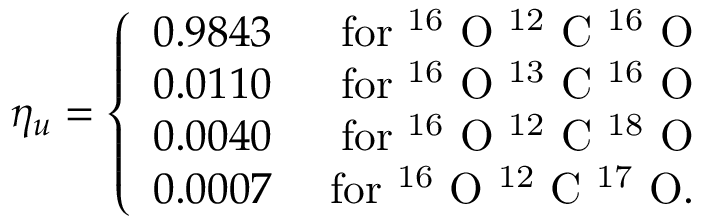<formula> <loc_0><loc_0><loc_500><loc_500>\eta _ { u } = \left \{ \begin{array} { r r } { 0 . 9 8 4 3 } & { f o r ^ { 1 6 } O ^ { 1 2 } C ^ { 1 6 } O } \\ { 0 . 0 1 1 0 } & { f o r ^ { 1 6 } O ^ { 1 3 } C ^ { 1 6 } O } \\ { 0 . 0 0 4 0 } & { f o r ^ { 1 6 } O ^ { 1 2 } C ^ { 1 8 } O } \\ { 0 . 0 0 0 7 } & { f o r ^ { 1 6 } O ^ { 1 2 } C ^ { 1 7 } O . } \end{array}</formula> 